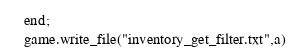<code> <loc_0><loc_0><loc_500><loc_500><_Lua_>end;
game.write_file("inventory_get_filter.txt",a)

</code> 